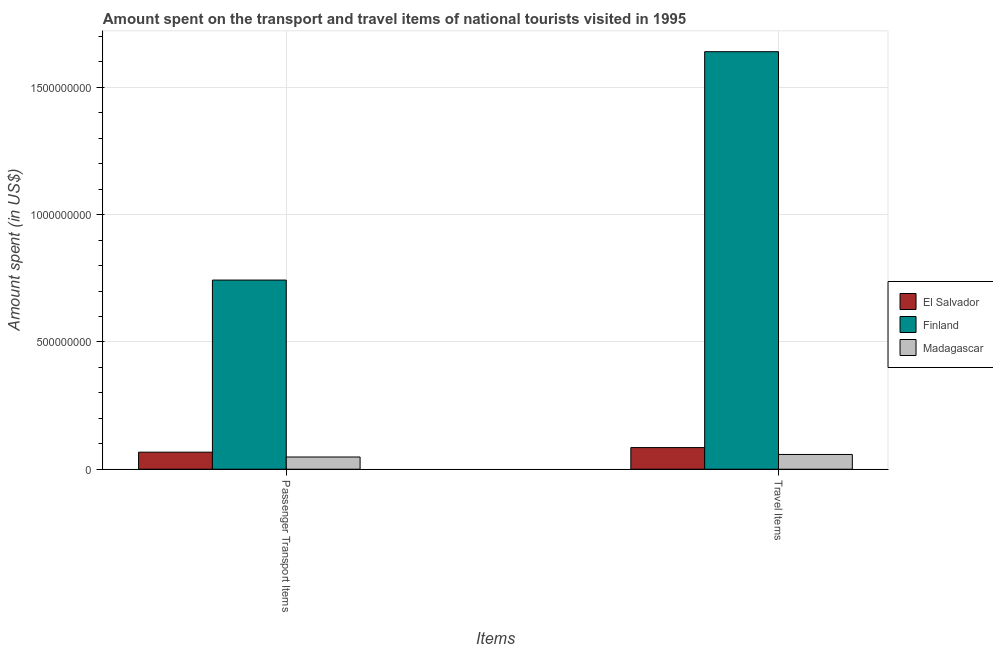How many different coloured bars are there?
Offer a very short reply. 3. How many groups of bars are there?
Your response must be concise. 2. Are the number of bars per tick equal to the number of legend labels?
Your response must be concise. Yes. How many bars are there on the 1st tick from the left?
Your answer should be very brief. 3. What is the label of the 1st group of bars from the left?
Your answer should be very brief. Passenger Transport Items. What is the amount spent on passenger transport items in Finland?
Provide a short and direct response. 7.43e+08. Across all countries, what is the maximum amount spent on passenger transport items?
Your response must be concise. 7.43e+08. Across all countries, what is the minimum amount spent in travel items?
Offer a terse response. 5.80e+07. In which country was the amount spent on passenger transport items maximum?
Provide a short and direct response. Finland. In which country was the amount spent in travel items minimum?
Offer a very short reply. Madagascar. What is the total amount spent on passenger transport items in the graph?
Offer a very short reply. 8.58e+08. What is the difference between the amount spent in travel items in Madagascar and that in Finland?
Ensure brevity in your answer.  -1.58e+09. What is the difference between the amount spent in travel items in El Salvador and the amount spent on passenger transport items in Finland?
Your answer should be very brief. -6.58e+08. What is the average amount spent on passenger transport items per country?
Your answer should be very brief. 2.86e+08. What is the difference between the amount spent on passenger transport items and amount spent in travel items in El Salvador?
Your answer should be very brief. -1.80e+07. What is the ratio of the amount spent on passenger transport items in El Salvador to that in Finland?
Offer a very short reply. 0.09. Is the amount spent on passenger transport items in Madagascar less than that in Finland?
Offer a very short reply. Yes. What does the 1st bar from the left in Travel Items represents?
Your answer should be very brief. El Salvador. What does the 2nd bar from the right in Passenger Transport Items represents?
Ensure brevity in your answer.  Finland. How many bars are there?
Provide a succinct answer. 6. Are all the bars in the graph horizontal?
Offer a terse response. No. What is the difference between two consecutive major ticks on the Y-axis?
Make the answer very short. 5.00e+08. Are the values on the major ticks of Y-axis written in scientific E-notation?
Offer a terse response. No. Does the graph contain any zero values?
Provide a succinct answer. No. Does the graph contain grids?
Make the answer very short. Yes. Where does the legend appear in the graph?
Your response must be concise. Center right. How many legend labels are there?
Make the answer very short. 3. How are the legend labels stacked?
Provide a succinct answer. Vertical. What is the title of the graph?
Your answer should be very brief. Amount spent on the transport and travel items of national tourists visited in 1995. Does "Latin America(all income levels)" appear as one of the legend labels in the graph?
Offer a very short reply. No. What is the label or title of the X-axis?
Give a very brief answer. Items. What is the label or title of the Y-axis?
Ensure brevity in your answer.  Amount spent (in US$). What is the Amount spent (in US$) in El Salvador in Passenger Transport Items?
Provide a short and direct response. 6.70e+07. What is the Amount spent (in US$) of Finland in Passenger Transport Items?
Offer a very short reply. 7.43e+08. What is the Amount spent (in US$) of Madagascar in Passenger Transport Items?
Ensure brevity in your answer.  4.80e+07. What is the Amount spent (in US$) of El Salvador in Travel Items?
Offer a terse response. 8.50e+07. What is the Amount spent (in US$) in Finland in Travel Items?
Provide a succinct answer. 1.64e+09. What is the Amount spent (in US$) of Madagascar in Travel Items?
Offer a terse response. 5.80e+07. Across all Items, what is the maximum Amount spent (in US$) of El Salvador?
Your answer should be compact. 8.50e+07. Across all Items, what is the maximum Amount spent (in US$) of Finland?
Provide a short and direct response. 1.64e+09. Across all Items, what is the maximum Amount spent (in US$) of Madagascar?
Make the answer very short. 5.80e+07. Across all Items, what is the minimum Amount spent (in US$) of El Salvador?
Your response must be concise. 6.70e+07. Across all Items, what is the minimum Amount spent (in US$) of Finland?
Offer a terse response. 7.43e+08. Across all Items, what is the minimum Amount spent (in US$) in Madagascar?
Make the answer very short. 4.80e+07. What is the total Amount spent (in US$) in El Salvador in the graph?
Your answer should be very brief. 1.52e+08. What is the total Amount spent (in US$) in Finland in the graph?
Your answer should be very brief. 2.38e+09. What is the total Amount spent (in US$) in Madagascar in the graph?
Give a very brief answer. 1.06e+08. What is the difference between the Amount spent (in US$) in El Salvador in Passenger Transport Items and that in Travel Items?
Offer a very short reply. -1.80e+07. What is the difference between the Amount spent (in US$) of Finland in Passenger Transport Items and that in Travel Items?
Ensure brevity in your answer.  -8.97e+08. What is the difference between the Amount spent (in US$) in Madagascar in Passenger Transport Items and that in Travel Items?
Ensure brevity in your answer.  -1.00e+07. What is the difference between the Amount spent (in US$) of El Salvador in Passenger Transport Items and the Amount spent (in US$) of Finland in Travel Items?
Your answer should be very brief. -1.57e+09. What is the difference between the Amount spent (in US$) in El Salvador in Passenger Transport Items and the Amount spent (in US$) in Madagascar in Travel Items?
Offer a terse response. 9.00e+06. What is the difference between the Amount spent (in US$) of Finland in Passenger Transport Items and the Amount spent (in US$) of Madagascar in Travel Items?
Your answer should be very brief. 6.85e+08. What is the average Amount spent (in US$) in El Salvador per Items?
Offer a very short reply. 7.60e+07. What is the average Amount spent (in US$) in Finland per Items?
Offer a very short reply. 1.19e+09. What is the average Amount spent (in US$) of Madagascar per Items?
Provide a short and direct response. 5.30e+07. What is the difference between the Amount spent (in US$) in El Salvador and Amount spent (in US$) in Finland in Passenger Transport Items?
Ensure brevity in your answer.  -6.76e+08. What is the difference between the Amount spent (in US$) in El Salvador and Amount spent (in US$) in Madagascar in Passenger Transport Items?
Keep it short and to the point. 1.90e+07. What is the difference between the Amount spent (in US$) in Finland and Amount spent (in US$) in Madagascar in Passenger Transport Items?
Keep it short and to the point. 6.95e+08. What is the difference between the Amount spent (in US$) in El Salvador and Amount spent (in US$) in Finland in Travel Items?
Your answer should be very brief. -1.56e+09. What is the difference between the Amount spent (in US$) of El Salvador and Amount spent (in US$) of Madagascar in Travel Items?
Your answer should be compact. 2.70e+07. What is the difference between the Amount spent (in US$) in Finland and Amount spent (in US$) in Madagascar in Travel Items?
Make the answer very short. 1.58e+09. What is the ratio of the Amount spent (in US$) of El Salvador in Passenger Transport Items to that in Travel Items?
Your answer should be very brief. 0.79. What is the ratio of the Amount spent (in US$) in Finland in Passenger Transport Items to that in Travel Items?
Make the answer very short. 0.45. What is the ratio of the Amount spent (in US$) in Madagascar in Passenger Transport Items to that in Travel Items?
Offer a very short reply. 0.83. What is the difference between the highest and the second highest Amount spent (in US$) of El Salvador?
Your answer should be very brief. 1.80e+07. What is the difference between the highest and the second highest Amount spent (in US$) of Finland?
Give a very brief answer. 8.97e+08. What is the difference between the highest and the second highest Amount spent (in US$) in Madagascar?
Give a very brief answer. 1.00e+07. What is the difference between the highest and the lowest Amount spent (in US$) in El Salvador?
Provide a short and direct response. 1.80e+07. What is the difference between the highest and the lowest Amount spent (in US$) in Finland?
Ensure brevity in your answer.  8.97e+08. 